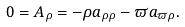<formula> <loc_0><loc_0><loc_500><loc_500>0 = A _ { \rho } = - \rho a _ { \rho \rho } - \varpi a _ { \varpi \rho } .</formula> 